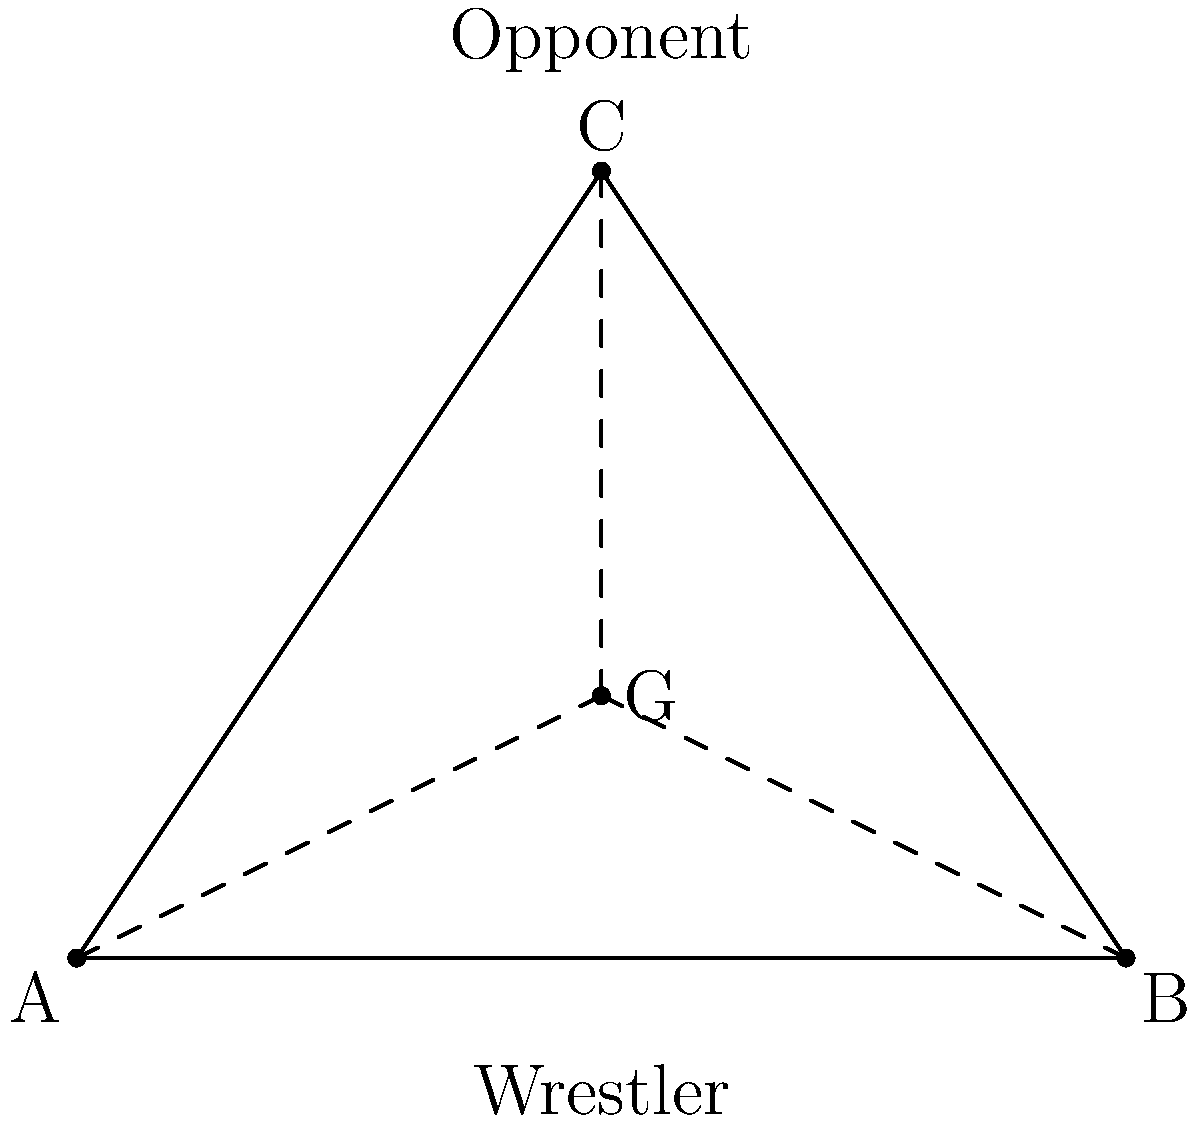In a wrestling throw, you need to visualize the center of gravity (G) of the combined system (you and your opponent). Given the triangle ABC represents the system, with A and B being your feet positions and C being your opponent's center of mass, where should the combined center of gravity G be located for optimal throw execution? To determine the optimal location of the combined center of gravity G for executing a wrestling throw, we need to consider the following steps:

1. Recognize that the triangle ABC represents the base of support (between your feet) and the opponent's position.

2. For a stable and powerful throw, the combined center of gravity G should be:
   a) Inside the triangle ABC
   b) Closer to your base of support (line AB) than to the opponent (point C)

3. The ideal position for G would be:
   a) Approximately 1/3 of the way from AB to C
   b) Centrally located between A and B

4. This position allows for:
   a) Maintaining balance during the throw
   b) Generating maximum rotational force
   c) Efficient weight transfer from you to your opponent

5. In the diagram, G is positioned at (2,1), which satisfies these conditions:
   a) It's inside triangle ABC
   b) It's closer to AB than to C
   c) It's about 1/3 of the way from AB to C
   d) It's centrally located between A and B

6. This position of G allows you to use your lower body strength effectively while maintaining control over your opponent's weight during the throw.
Answer: 1/3 from base to opponent, centered 